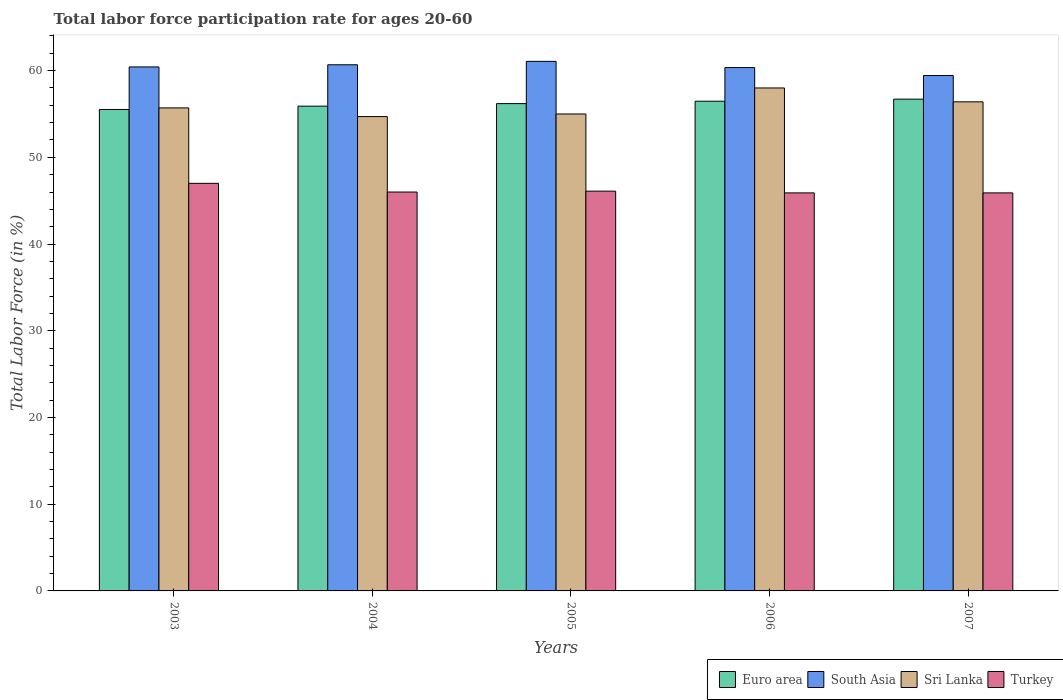How many different coloured bars are there?
Provide a succinct answer. 4. How many bars are there on the 2nd tick from the left?
Give a very brief answer. 4. In how many cases, is the number of bars for a given year not equal to the number of legend labels?
Give a very brief answer. 0. Across all years, what is the maximum labor force participation rate in Euro area?
Keep it short and to the point. 56.71. Across all years, what is the minimum labor force participation rate in Euro area?
Your response must be concise. 55.52. In which year was the labor force participation rate in Turkey maximum?
Your answer should be very brief. 2003. In which year was the labor force participation rate in South Asia minimum?
Your answer should be compact. 2007. What is the total labor force participation rate in Turkey in the graph?
Keep it short and to the point. 230.9. What is the difference between the labor force participation rate in South Asia in 2004 and that in 2007?
Offer a very short reply. 1.24. What is the difference between the labor force participation rate in Turkey in 2005 and the labor force participation rate in Sri Lanka in 2006?
Offer a very short reply. -11.9. What is the average labor force participation rate in Turkey per year?
Offer a terse response. 46.18. In the year 2005, what is the difference between the labor force participation rate in Turkey and labor force participation rate in Euro area?
Your response must be concise. -10.09. In how many years, is the labor force participation rate in Euro area greater than 12 %?
Provide a succinct answer. 5. What is the ratio of the labor force participation rate in South Asia in 2005 to that in 2006?
Your response must be concise. 1.01. What is the difference between the highest and the second highest labor force participation rate in Turkey?
Ensure brevity in your answer.  0.9. What is the difference between the highest and the lowest labor force participation rate in Turkey?
Make the answer very short. 1.1. In how many years, is the labor force participation rate in Turkey greater than the average labor force participation rate in Turkey taken over all years?
Offer a very short reply. 1. Is the sum of the labor force participation rate in South Asia in 2005 and 2007 greater than the maximum labor force participation rate in Sri Lanka across all years?
Offer a terse response. Yes. What does the 2nd bar from the left in 2004 represents?
Offer a terse response. South Asia. What does the 4th bar from the right in 2005 represents?
Give a very brief answer. Euro area. What is the difference between two consecutive major ticks on the Y-axis?
Your answer should be compact. 10. Are the values on the major ticks of Y-axis written in scientific E-notation?
Your response must be concise. No. Does the graph contain any zero values?
Ensure brevity in your answer.  No. What is the title of the graph?
Keep it short and to the point. Total labor force participation rate for ages 20-60. Does "Caribbean small states" appear as one of the legend labels in the graph?
Keep it short and to the point. No. What is the label or title of the X-axis?
Make the answer very short. Years. What is the Total Labor Force (in %) of Euro area in 2003?
Offer a terse response. 55.52. What is the Total Labor Force (in %) of South Asia in 2003?
Your answer should be compact. 60.43. What is the Total Labor Force (in %) in Sri Lanka in 2003?
Your response must be concise. 55.7. What is the Total Labor Force (in %) in Turkey in 2003?
Give a very brief answer. 47. What is the Total Labor Force (in %) of Euro area in 2004?
Ensure brevity in your answer.  55.9. What is the Total Labor Force (in %) of South Asia in 2004?
Ensure brevity in your answer.  60.67. What is the Total Labor Force (in %) of Sri Lanka in 2004?
Make the answer very short. 54.7. What is the Total Labor Force (in %) of Euro area in 2005?
Your answer should be very brief. 56.19. What is the Total Labor Force (in %) of South Asia in 2005?
Your answer should be very brief. 61.07. What is the Total Labor Force (in %) in Sri Lanka in 2005?
Offer a very short reply. 55. What is the Total Labor Force (in %) of Turkey in 2005?
Make the answer very short. 46.1. What is the Total Labor Force (in %) of Euro area in 2006?
Provide a succinct answer. 56.47. What is the Total Labor Force (in %) of South Asia in 2006?
Your answer should be very brief. 60.35. What is the Total Labor Force (in %) of Turkey in 2006?
Your answer should be very brief. 45.9. What is the Total Labor Force (in %) of Euro area in 2007?
Provide a short and direct response. 56.71. What is the Total Labor Force (in %) of South Asia in 2007?
Keep it short and to the point. 59.44. What is the Total Labor Force (in %) in Sri Lanka in 2007?
Your response must be concise. 56.4. What is the Total Labor Force (in %) of Turkey in 2007?
Keep it short and to the point. 45.9. Across all years, what is the maximum Total Labor Force (in %) of Euro area?
Offer a terse response. 56.71. Across all years, what is the maximum Total Labor Force (in %) of South Asia?
Offer a very short reply. 61.07. Across all years, what is the maximum Total Labor Force (in %) of Turkey?
Your answer should be very brief. 47. Across all years, what is the minimum Total Labor Force (in %) of Euro area?
Give a very brief answer. 55.52. Across all years, what is the minimum Total Labor Force (in %) of South Asia?
Keep it short and to the point. 59.44. Across all years, what is the minimum Total Labor Force (in %) of Sri Lanka?
Provide a succinct answer. 54.7. Across all years, what is the minimum Total Labor Force (in %) in Turkey?
Offer a terse response. 45.9. What is the total Total Labor Force (in %) of Euro area in the graph?
Provide a succinct answer. 280.8. What is the total Total Labor Force (in %) in South Asia in the graph?
Keep it short and to the point. 301.96. What is the total Total Labor Force (in %) of Sri Lanka in the graph?
Ensure brevity in your answer.  279.8. What is the total Total Labor Force (in %) of Turkey in the graph?
Provide a succinct answer. 230.9. What is the difference between the Total Labor Force (in %) in Euro area in 2003 and that in 2004?
Your response must be concise. -0.38. What is the difference between the Total Labor Force (in %) in South Asia in 2003 and that in 2004?
Ensure brevity in your answer.  -0.25. What is the difference between the Total Labor Force (in %) of Euro area in 2003 and that in 2005?
Your answer should be very brief. -0.68. What is the difference between the Total Labor Force (in %) in South Asia in 2003 and that in 2005?
Provide a succinct answer. -0.64. What is the difference between the Total Labor Force (in %) in Euro area in 2003 and that in 2006?
Your answer should be compact. -0.95. What is the difference between the Total Labor Force (in %) in South Asia in 2003 and that in 2006?
Your answer should be compact. 0.07. What is the difference between the Total Labor Force (in %) of Euro area in 2003 and that in 2007?
Offer a terse response. -1.19. What is the difference between the Total Labor Force (in %) of South Asia in 2003 and that in 2007?
Make the answer very short. 0.99. What is the difference between the Total Labor Force (in %) in Sri Lanka in 2003 and that in 2007?
Ensure brevity in your answer.  -0.7. What is the difference between the Total Labor Force (in %) of Euro area in 2004 and that in 2005?
Make the answer very short. -0.29. What is the difference between the Total Labor Force (in %) in South Asia in 2004 and that in 2005?
Your answer should be very brief. -0.39. What is the difference between the Total Labor Force (in %) of Euro area in 2004 and that in 2006?
Make the answer very short. -0.57. What is the difference between the Total Labor Force (in %) of South Asia in 2004 and that in 2006?
Make the answer very short. 0.32. What is the difference between the Total Labor Force (in %) of Sri Lanka in 2004 and that in 2006?
Provide a succinct answer. -3.3. What is the difference between the Total Labor Force (in %) in Turkey in 2004 and that in 2006?
Provide a short and direct response. 0.1. What is the difference between the Total Labor Force (in %) in Euro area in 2004 and that in 2007?
Provide a short and direct response. -0.81. What is the difference between the Total Labor Force (in %) in South Asia in 2004 and that in 2007?
Your answer should be compact. 1.24. What is the difference between the Total Labor Force (in %) of Sri Lanka in 2004 and that in 2007?
Ensure brevity in your answer.  -1.7. What is the difference between the Total Labor Force (in %) in Euro area in 2005 and that in 2006?
Keep it short and to the point. -0.28. What is the difference between the Total Labor Force (in %) in South Asia in 2005 and that in 2006?
Your answer should be very brief. 0.72. What is the difference between the Total Labor Force (in %) of Turkey in 2005 and that in 2006?
Offer a very short reply. 0.2. What is the difference between the Total Labor Force (in %) in Euro area in 2005 and that in 2007?
Keep it short and to the point. -0.52. What is the difference between the Total Labor Force (in %) in South Asia in 2005 and that in 2007?
Your response must be concise. 1.63. What is the difference between the Total Labor Force (in %) in Sri Lanka in 2005 and that in 2007?
Ensure brevity in your answer.  -1.4. What is the difference between the Total Labor Force (in %) in Turkey in 2005 and that in 2007?
Offer a very short reply. 0.2. What is the difference between the Total Labor Force (in %) in Euro area in 2006 and that in 2007?
Your response must be concise. -0.24. What is the difference between the Total Labor Force (in %) of Euro area in 2003 and the Total Labor Force (in %) of South Asia in 2004?
Give a very brief answer. -5.16. What is the difference between the Total Labor Force (in %) in Euro area in 2003 and the Total Labor Force (in %) in Sri Lanka in 2004?
Your response must be concise. 0.82. What is the difference between the Total Labor Force (in %) in Euro area in 2003 and the Total Labor Force (in %) in Turkey in 2004?
Make the answer very short. 9.52. What is the difference between the Total Labor Force (in %) of South Asia in 2003 and the Total Labor Force (in %) of Sri Lanka in 2004?
Offer a very short reply. 5.73. What is the difference between the Total Labor Force (in %) in South Asia in 2003 and the Total Labor Force (in %) in Turkey in 2004?
Keep it short and to the point. 14.43. What is the difference between the Total Labor Force (in %) of Euro area in 2003 and the Total Labor Force (in %) of South Asia in 2005?
Give a very brief answer. -5.55. What is the difference between the Total Labor Force (in %) in Euro area in 2003 and the Total Labor Force (in %) in Sri Lanka in 2005?
Keep it short and to the point. 0.52. What is the difference between the Total Labor Force (in %) in Euro area in 2003 and the Total Labor Force (in %) in Turkey in 2005?
Make the answer very short. 9.42. What is the difference between the Total Labor Force (in %) of South Asia in 2003 and the Total Labor Force (in %) of Sri Lanka in 2005?
Your answer should be very brief. 5.43. What is the difference between the Total Labor Force (in %) of South Asia in 2003 and the Total Labor Force (in %) of Turkey in 2005?
Your response must be concise. 14.33. What is the difference between the Total Labor Force (in %) of Euro area in 2003 and the Total Labor Force (in %) of South Asia in 2006?
Keep it short and to the point. -4.83. What is the difference between the Total Labor Force (in %) in Euro area in 2003 and the Total Labor Force (in %) in Sri Lanka in 2006?
Your answer should be compact. -2.48. What is the difference between the Total Labor Force (in %) in Euro area in 2003 and the Total Labor Force (in %) in Turkey in 2006?
Your answer should be compact. 9.62. What is the difference between the Total Labor Force (in %) of South Asia in 2003 and the Total Labor Force (in %) of Sri Lanka in 2006?
Make the answer very short. 2.43. What is the difference between the Total Labor Force (in %) of South Asia in 2003 and the Total Labor Force (in %) of Turkey in 2006?
Offer a terse response. 14.53. What is the difference between the Total Labor Force (in %) of Euro area in 2003 and the Total Labor Force (in %) of South Asia in 2007?
Your answer should be very brief. -3.92. What is the difference between the Total Labor Force (in %) in Euro area in 2003 and the Total Labor Force (in %) in Sri Lanka in 2007?
Provide a short and direct response. -0.88. What is the difference between the Total Labor Force (in %) in Euro area in 2003 and the Total Labor Force (in %) in Turkey in 2007?
Your answer should be very brief. 9.62. What is the difference between the Total Labor Force (in %) of South Asia in 2003 and the Total Labor Force (in %) of Sri Lanka in 2007?
Keep it short and to the point. 4.03. What is the difference between the Total Labor Force (in %) of South Asia in 2003 and the Total Labor Force (in %) of Turkey in 2007?
Your response must be concise. 14.53. What is the difference between the Total Labor Force (in %) of Euro area in 2004 and the Total Labor Force (in %) of South Asia in 2005?
Your answer should be very brief. -5.17. What is the difference between the Total Labor Force (in %) in Euro area in 2004 and the Total Labor Force (in %) in Sri Lanka in 2005?
Offer a terse response. 0.9. What is the difference between the Total Labor Force (in %) in Euro area in 2004 and the Total Labor Force (in %) in Turkey in 2005?
Ensure brevity in your answer.  9.8. What is the difference between the Total Labor Force (in %) of South Asia in 2004 and the Total Labor Force (in %) of Sri Lanka in 2005?
Your response must be concise. 5.67. What is the difference between the Total Labor Force (in %) of South Asia in 2004 and the Total Labor Force (in %) of Turkey in 2005?
Offer a very short reply. 14.57. What is the difference between the Total Labor Force (in %) of Sri Lanka in 2004 and the Total Labor Force (in %) of Turkey in 2005?
Provide a short and direct response. 8.6. What is the difference between the Total Labor Force (in %) of Euro area in 2004 and the Total Labor Force (in %) of South Asia in 2006?
Provide a short and direct response. -4.45. What is the difference between the Total Labor Force (in %) of Euro area in 2004 and the Total Labor Force (in %) of Sri Lanka in 2006?
Give a very brief answer. -2.1. What is the difference between the Total Labor Force (in %) of Euro area in 2004 and the Total Labor Force (in %) of Turkey in 2006?
Provide a succinct answer. 10. What is the difference between the Total Labor Force (in %) of South Asia in 2004 and the Total Labor Force (in %) of Sri Lanka in 2006?
Provide a short and direct response. 2.67. What is the difference between the Total Labor Force (in %) of South Asia in 2004 and the Total Labor Force (in %) of Turkey in 2006?
Offer a very short reply. 14.77. What is the difference between the Total Labor Force (in %) of Euro area in 2004 and the Total Labor Force (in %) of South Asia in 2007?
Your answer should be very brief. -3.53. What is the difference between the Total Labor Force (in %) in Euro area in 2004 and the Total Labor Force (in %) in Sri Lanka in 2007?
Make the answer very short. -0.5. What is the difference between the Total Labor Force (in %) of Euro area in 2004 and the Total Labor Force (in %) of Turkey in 2007?
Your answer should be compact. 10. What is the difference between the Total Labor Force (in %) of South Asia in 2004 and the Total Labor Force (in %) of Sri Lanka in 2007?
Give a very brief answer. 4.27. What is the difference between the Total Labor Force (in %) in South Asia in 2004 and the Total Labor Force (in %) in Turkey in 2007?
Offer a very short reply. 14.77. What is the difference between the Total Labor Force (in %) of Sri Lanka in 2004 and the Total Labor Force (in %) of Turkey in 2007?
Keep it short and to the point. 8.8. What is the difference between the Total Labor Force (in %) in Euro area in 2005 and the Total Labor Force (in %) in South Asia in 2006?
Make the answer very short. -4.16. What is the difference between the Total Labor Force (in %) of Euro area in 2005 and the Total Labor Force (in %) of Sri Lanka in 2006?
Your answer should be compact. -1.81. What is the difference between the Total Labor Force (in %) of Euro area in 2005 and the Total Labor Force (in %) of Turkey in 2006?
Your answer should be very brief. 10.29. What is the difference between the Total Labor Force (in %) of South Asia in 2005 and the Total Labor Force (in %) of Sri Lanka in 2006?
Your response must be concise. 3.07. What is the difference between the Total Labor Force (in %) in South Asia in 2005 and the Total Labor Force (in %) in Turkey in 2006?
Give a very brief answer. 15.17. What is the difference between the Total Labor Force (in %) of Euro area in 2005 and the Total Labor Force (in %) of South Asia in 2007?
Your answer should be compact. -3.24. What is the difference between the Total Labor Force (in %) of Euro area in 2005 and the Total Labor Force (in %) of Sri Lanka in 2007?
Keep it short and to the point. -0.21. What is the difference between the Total Labor Force (in %) of Euro area in 2005 and the Total Labor Force (in %) of Turkey in 2007?
Offer a very short reply. 10.29. What is the difference between the Total Labor Force (in %) in South Asia in 2005 and the Total Labor Force (in %) in Sri Lanka in 2007?
Provide a short and direct response. 4.67. What is the difference between the Total Labor Force (in %) in South Asia in 2005 and the Total Labor Force (in %) in Turkey in 2007?
Your answer should be compact. 15.17. What is the difference between the Total Labor Force (in %) of Euro area in 2006 and the Total Labor Force (in %) of South Asia in 2007?
Offer a very short reply. -2.96. What is the difference between the Total Labor Force (in %) in Euro area in 2006 and the Total Labor Force (in %) in Sri Lanka in 2007?
Your response must be concise. 0.07. What is the difference between the Total Labor Force (in %) in Euro area in 2006 and the Total Labor Force (in %) in Turkey in 2007?
Offer a very short reply. 10.57. What is the difference between the Total Labor Force (in %) in South Asia in 2006 and the Total Labor Force (in %) in Sri Lanka in 2007?
Provide a short and direct response. 3.95. What is the difference between the Total Labor Force (in %) of South Asia in 2006 and the Total Labor Force (in %) of Turkey in 2007?
Offer a terse response. 14.45. What is the difference between the Total Labor Force (in %) in Sri Lanka in 2006 and the Total Labor Force (in %) in Turkey in 2007?
Provide a short and direct response. 12.1. What is the average Total Labor Force (in %) in Euro area per year?
Your answer should be very brief. 56.16. What is the average Total Labor Force (in %) of South Asia per year?
Your answer should be compact. 60.39. What is the average Total Labor Force (in %) of Sri Lanka per year?
Offer a terse response. 55.96. What is the average Total Labor Force (in %) of Turkey per year?
Ensure brevity in your answer.  46.18. In the year 2003, what is the difference between the Total Labor Force (in %) of Euro area and Total Labor Force (in %) of South Asia?
Provide a short and direct response. -4.91. In the year 2003, what is the difference between the Total Labor Force (in %) of Euro area and Total Labor Force (in %) of Sri Lanka?
Give a very brief answer. -0.18. In the year 2003, what is the difference between the Total Labor Force (in %) in Euro area and Total Labor Force (in %) in Turkey?
Make the answer very short. 8.52. In the year 2003, what is the difference between the Total Labor Force (in %) of South Asia and Total Labor Force (in %) of Sri Lanka?
Ensure brevity in your answer.  4.73. In the year 2003, what is the difference between the Total Labor Force (in %) in South Asia and Total Labor Force (in %) in Turkey?
Provide a short and direct response. 13.43. In the year 2004, what is the difference between the Total Labor Force (in %) in Euro area and Total Labor Force (in %) in South Asia?
Provide a short and direct response. -4.77. In the year 2004, what is the difference between the Total Labor Force (in %) in Euro area and Total Labor Force (in %) in Sri Lanka?
Offer a terse response. 1.2. In the year 2004, what is the difference between the Total Labor Force (in %) in Euro area and Total Labor Force (in %) in Turkey?
Provide a short and direct response. 9.9. In the year 2004, what is the difference between the Total Labor Force (in %) in South Asia and Total Labor Force (in %) in Sri Lanka?
Provide a short and direct response. 5.97. In the year 2004, what is the difference between the Total Labor Force (in %) of South Asia and Total Labor Force (in %) of Turkey?
Offer a terse response. 14.67. In the year 2004, what is the difference between the Total Labor Force (in %) in Sri Lanka and Total Labor Force (in %) in Turkey?
Your response must be concise. 8.7. In the year 2005, what is the difference between the Total Labor Force (in %) of Euro area and Total Labor Force (in %) of South Asia?
Give a very brief answer. -4.87. In the year 2005, what is the difference between the Total Labor Force (in %) in Euro area and Total Labor Force (in %) in Sri Lanka?
Offer a terse response. 1.19. In the year 2005, what is the difference between the Total Labor Force (in %) in Euro area and Total Labor Force (in %) in Turkey?
Provide a succinct answer. 10.09. In the year 2005, what is the difference between the Total Labor Force (in %) of South Asia and Total Labor Force (in %) of Sri Lanka?
Provide a succinct answer. 6.07. In the year 2005, what is the difference between the Total Labor Force (in %) of South Asia and Total Labor Force (in %) of Turkey?
Make the answer very short. 14.97. In the year 2005, what is the difference between the Total Labor Force (in %) in Sri Lanka and Total Labor Force (in %) in Turkey?
Ensure brevity in your answer.  8.9. In the year 2006, what is the difference between the Total Labor Force (in %) of Euro area and Total Labor Force (in %) of South Asia?
Offer a terse response. -3.88. In the year 2006, what is the difference between the Total Labor Force (in %) in Euro area and Total Labor Force (in %) in Sri Lanka?
Give a very brief answer. -1.53. In the year 2006, what is the difference between the Total Labor Force (in %) of Euro area and Total Labor Force (in %) of Turkey?
Give a very brief answer. 10.57. In the year 2006, what is the difference between the Total Labor Force (in %) in South Asia and Total Labor Force (in %) in Sri Lanka?
Make the answer very short. 2.35. In the year 2006, what is the difference between the Total Labor Force (in %) in South Asia and Total Labor Force (in %) in Turkey?
Offer a terse response. 14.45. In the year 2007, what is the difference between the Total Labor Force (in %) of Euro area and Total Labor Force (in %) of South Asia?
Your answer should be compact. -2.72. In the year 2007, what is the difference between the Total Labor Force (in %) in Euro area and Total Labor Force (in %) in Sri Lanka?
Your response must be concise. 0.31. In the year 2007, what is the difference between the Total Labor Force (in %) in Euro area and Total Labor Force (in %) in Turkey?
Ensure brevity in your answer.  10.81. In the year 2007, what is the difference between the Total Labor Force (in %) of South Asia and Total Labor Force (in %) of Sri Lanka?
Give a very brief answer. 3.04. In the year 2007, what is the difference between the Total Labor Force (in %) of South Asia and Total Labor Force (in %) of Turkey?
Your response must be concise. 13.54. What is the ratio of the Total Labor Force (in %) of Sri Lanka in 2003 to that in 2004?
Offer a terse response. 1.02. What is the ratio of the Total Labor Force (in %) of Turkey in 2003 to that in 2004?
Provide a succinct answer. 1.02. What is the ratio of the Total Labor Force (in %) in Sri Lanka in 2003 to that in 2005?
Your answer should be compact. 1.01. What is the ratio of the Total Labor Force (in %) in Turkey in 2003 to that in 2005?
Provide a short and direct response. 1.02. What is the ratio of the Total Labor Force (in %) in Euro area in 2003 to that in 2006?
Your answer should be very brief. 0.98. What is the ratio of the Total Labor Force (in %) of South Asia in 2003 to that in 2006?
Provide a succinct answer. 1. What is the ratio of the Total Labor Force (in %) of Sri Lanka in 2003 to that in 2006?
Ensure brevity in your answer.  0.96. What is the ratio of the Total Labor Force (in %) in Turkey in 2003 to that in 2006?
Make the answer very short. 1.02. What is the ratio of the Total Labor Force (in %) in Euro area in 2003 to that in 2007?
Offer a terse response. 0.98. What is the ratio of the Total Labor Force (in %) of South Asia in 2003 to that in 2007?
Provide a short and direct response. 1.02. What is the ratio of the Total Labor Force (in %) in Sri Lanka in 2003 to that in 2007?
Your answer should be very brief. 0.99. What is the ratio of the Total Labor Force (in %) of Sri Lanka in 2004 to that in 2005?
Offer a terse response. 0.99. What is the ratio of the Total Labor Force (in %) in Turkey in 2004 to that in 2005?
Provide a succinct answer. 1. What is the ratio of the Total Labor Force (in %) of Euro area in 2004 to that in 2006?
Provide a short and direct response. 0.99. What is the ratio of the Total Labor Force (in %) in Sri Lanka in 2004 to that in 2006?
Provide a succinct answer. 0.94. What is the ratio of the Total Labor Force (in %) of Turkey in 2004 to that in 2006?
Provide a short and direct response. 1. What is the ratio of the Total Labor Force (in %) of Euro area in 2004 to that in 2007?
Offer a terse response. 0.99. What is the ratio of the Total Labor Force (in %) in South Asia in 2004 to that in 2007?
Provide a succinct answer. 1.02. What is the ratio of the Total Labor Force (in %) of Sri Lanka in 2004 to that in 2007?
Offer a very short reply. 0.97. What is the ratio of the Total Labor Force (in %) of Turkey in 2004 to that in 2007?
Make the answer very short. 1. What is the ratio of the Total Labor Force (in %) in Euro area in 2005 to that in 2006?
Your answer should be very brief. 1. What is the ratio of the Total Labor Force (in %) in South Asia in 2005 to that in 2006?
Offer a very short reply. 1.01. What is the ratio of the Total Labor Force (in %) in Sri Lanka in 2005 to that in 2006?
Make the answer very short. 0.95. What is the ratio of the Total Labor Force (in %) in Euro area in 2005 to that in 2007?
Your response must be concise. 0.99. What is the ratio of the Total Labor Force (in %) of South Asia in 2005 to that in 2007?
Offer a very short reply. 1.03. What is the ratio of the Total Labor Force (in %) in Sri Lanka in 2005 to that in 2007?
Provide a short and direct response. 0.98. What is the ratio of the Total Labor Force (in %) of Euro area in 2006 to that in 2007?
Provide a succinct answer. 1. What is the ratio of the Total Labor Force (in %) in South Asia in 2006 to that in 2007?
Ensure brevity in your answer.  1.02. What is the ratio of the Total Labor Force (in %) in Sri Lanka in 2006 to that in 2007?
Ensure brevity in your answer.  1.03. What is the ratio of the Total Labor Force (in %) of Turkey in 2006 to that in 2007?
Provide a short and direct response. 1. What is the difference between the highest and the second highest Total Labor Force (in %) of Euro area?
Offer a very short reply. 0.24. What is the difference between the highest and the second highest Total Labor Force (in %) in South Asia?
Provide a short and direct response. 0.39. What is the difference between the highest and the lowest Total Labor Force (in %) in Euro area?
Provide a short and direct response. 1.19. What is the difference between the highest and the lowest Total Labor Force (in %) of South Asia?
Provide a succinct answer. 1.63. What is the difference between the highest and the lowest Total Labor Force (in %) of Sri Lanka?
Offer a very short reply. 3.3. 